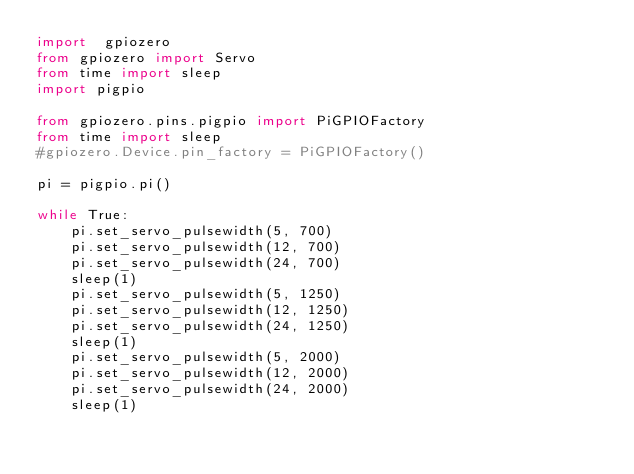<code> <loc_0><loc_0><loc_500><loc_500><_Python_>import  gpiozero
from gpiozero import Servo
from time import sleep
import pigpio

from gpiozero.pins.pigpio import PiGPIOFactory
from time import sleep
#gpiozero.Device.pin_factory = PiGPIOFactory()

pi = pigpio.pi()

while True:
    pi.set_servo_pulsewidth(5, 700)
    pi.set_servo_pulsewidth(12, 700)
    pi.set_servo_pulsewidth(24, 700)
    sleep(1)
    pi.set_servo_pulsewidth(5, 1250)
    pi.set_servo_pulsewidth(12, 1250)
    pi.set_servo_pulsewidth(24, 1250)
    sleep(1)
    pi.set_servo_pulsewidth(5, 2000)
    pi.set_servo_pulsewidth(12, 2000)
    pi.set_servo_pulsewidth(24, 2000)
    sleep(1)

</code> 